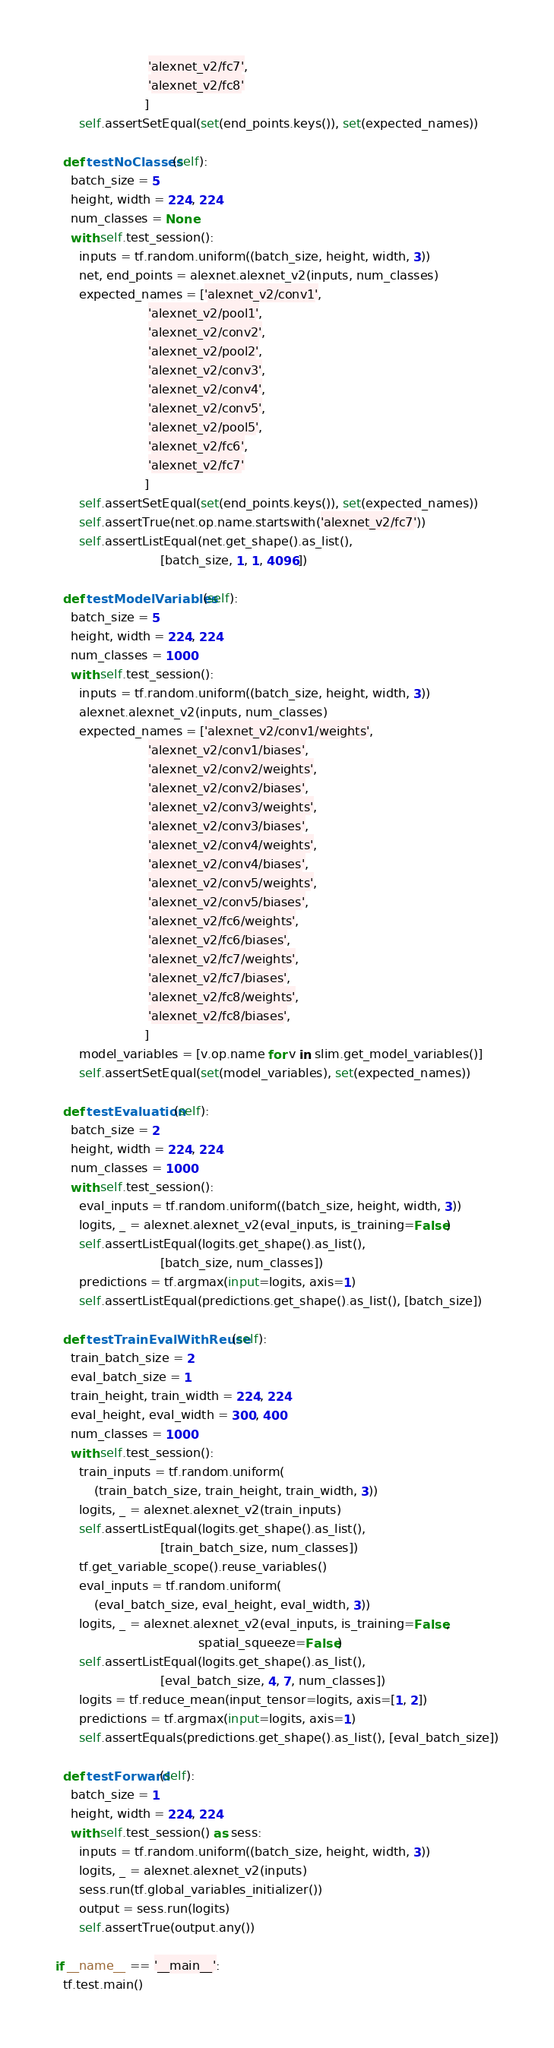Convert code to text. <code><loc_0><loc_0><loc_500><loc_500><_Python_>                        'alexnet_v2/fc7',
                        'alexnet_v2/fc8'
                       ]
      self.assertSetEqual(set(end_points.keys()), set(expected_names))

  def testNoClasses(self):
    batch_size = 5
    height, width = 224, 224
    num_classes = None
    with self.test_session():
      inputs = tf.random.uniform((batch_size, height, width, 3))
      net, end_points = alexnet.alexnet_v2(inputs, num_classes)
      expected_names = ['alexnet_v2/conv1',
                        'alexnet_v2/pool1',
                        'alexnet_v2/conv2',
                        'alexnet_v2/pool2',
                        'alexnet_v2/conv3',
                        'alexnet_v2/conv4',
                        'alexnet_v2/conv5',
                        'alexnet_v2/pool5',
                        'alexnet_v2/fc6',
                        'alexnet_v2/fc7'
                       ]
      self.assertSetEqual(set(end_points.keys()), set(expected_names))
      self.assertTrue(net.op.name.startswith('alexnet_v2/fc7'))
      self.assertListEqual(net.get_shape().as_list(),
                           [batch_size, 1, 1, 4096])

  def testModelVariables(self):
    batch_size = 5
    height, width = 224, 224
    num_classes = 1000
    with self.test_session():
      inputs = tf.random.uniform((batch_size, height, width, 3))
      alexnet.alexnet_v2(inputs, num_classes)
      expected_names = ['alexnet_v2/conv1/weights',
                        'alexnet_v2/conv1/biases',
                        'alexnet_v2/conv2/weights',
                        'alexnet_v2/conv2/biases',
                        'alexnet_v2/conv3/weights',
                        'alexnet_v2/conv3/biases',
                        'alexnet_v2/conv4/weights',
                        'alexnet_v2/conv4/biases',
                        'alexnet_v2/conv5/weights',
                        'alexnet_v2/conv5/biases',
                        'alexnet_v2/fc6/weights',
                        'alexnet_v2/fc6/biases',
                        'alexnet_v2/fc7/weights',
                        'alexnet_v2/fc7/biases',
                        'alexnet_v2/fc8/weights',
                        'alexnet_v2/fc8/biases',
                       ]
      model_variables = [v.op.name for v in slim.get_model_variables()]
      self.assertSetEqual(set(model_variables), set(expected_names))

  def testEvaluation(self):
    batch_size = 2
    height, width = 224, 224
    num_classes = 1000
    with self.test_session():
      eval_inputs = tf.random.uniform((batch_size, height, width, 3))
      logits, _ = alexnet.alexnet_v2(eval_inputs, is_training=False)
      self.assertListEqual(logits.get_shape().as_list(),
                           [batch_size, num_classes])
      predictions = tf.argmax(input=logits, axis=1)
      self.assertListEqual(predictions.get_shape().as_list(), [batch_size])

  def testTrainEvalWithReuse(self):
    train_batch_size = 2
    eval_batch_size = 1
    train_height, train_width = 224, 224
    eval_height, eval_width = 300, 400
    num_classes = 1000
    with self.test_session():
      train_inputs = tf.random.uniform(
          (train_batch_size, train_height, train_width, 3))
      logits, _ = alexnet.alexnet_v2(train_inputs)
      self.assertListEqual(logits.get_shape().as_list(),
                           [train_batch_size, num_classes])
      tf.get_variable_scope().reuse_variables()
      eval_inputs = tf.random.uniform(
          (eval_batch_size, eval_height, eval_width, 3))
      logits, _ = alexnet.alexnet_v2(eval_inputs, is_training=False,
                                     spatial_squeeze=False)
      self.assertListEqual(logits.get_shape().as_list(),
                           [eval_batch_size, 4, 7, num_classes])
      logits = tf.reduce_mean(input_tensor=logits, axis=[1, 2])
      predictions = tf.argmax(input=logits, axis=1)
      self.assertEquals(predictions.get_shape().as_list(), [eval_batch_size])

  def testForward(self):
    batch_size = 1
    height, width = 224, 224
    with self.test_session() as sess:
      inputs = tf.random.uniform((batch_size, height, width, 3))
      logits, _ = alexnet.alexnet_v2(inputs)
      sess.run(tf.global_variables_initializer())
      output = sess.run(logits)
      self.assertTrue(output.any())

if __name__ == '__main__':
  tf.test.main()
</code> 